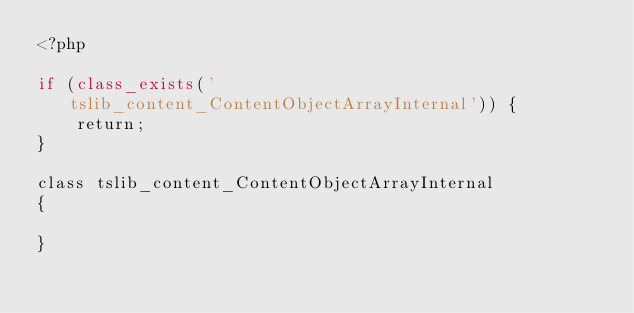Convert code to text. <code><loc_0><loc_0><loc_500><loc_500><_PHP_><?php

if (class_exists('tslib_content_ContentObjectArrayInternal')) {
    return;
}

class tslib_content_ContentObjectArrayInternal
{

}
</code> 